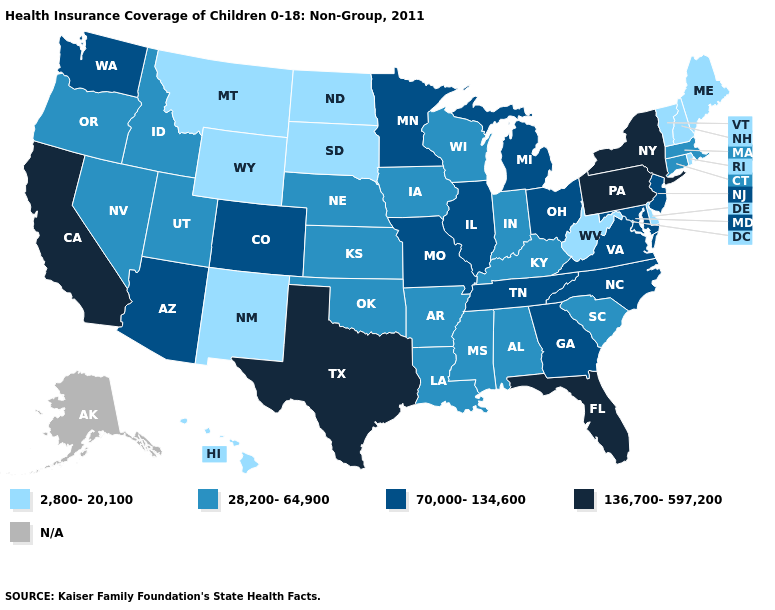Name the states that have a value in the range 28,200-64,900?
Keep it brief. Alabama, Arkansas, Connecticut, Idaho, Indiana, Iowa, Kansas, Kentucky, Louisiana, Massachusetts, Mississippi, Nebraska, Nevada, Oklahoma, Oregon, South Carolina, Utah, Wisconsin. Does the map have missing data?
Concise answer only. Yes. What is the value of West Virginia?
Concise answer only. 2,800-20,100. Does West Virginia have the lowest value in the USA?
Answer briefly. Yes. What is the highest value in states that border Wisconsin?
Be succinct. 70,000-134,600. How many symbols are there in the legend?
Concise answer only. 5. What is the highest value in states that border California?
Quick response, please. 70,000-134,600. Is the legend a continuous bar?
Be succinct. No. Does the first symbol in the legend represent the smallest category?
Answer briefly. Yes. What is the lowest value in states that border Missouri?
Concise answer only. 28,200-64,900. Name the states that have a value in the range 2,800-20,100?
Quick response, please. Delaware, Hawaii, Maine, Montana, New Hampshire, New Mexico, North Dakota, Rhode Island, South Dakota, Vermont, West Virginia, Wyoming. Name the states that have a value in the range N/A?
Quick response, please. Alaska. 